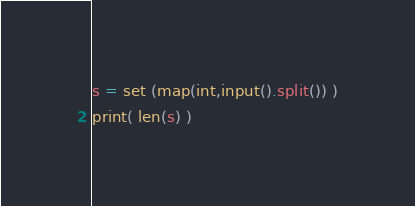Convert code to text. <code><loc_0><loc_0><loc_500><loc_500><_Python_>


s = set (map(int,input().split()) )
print( len(s) )
</code> 